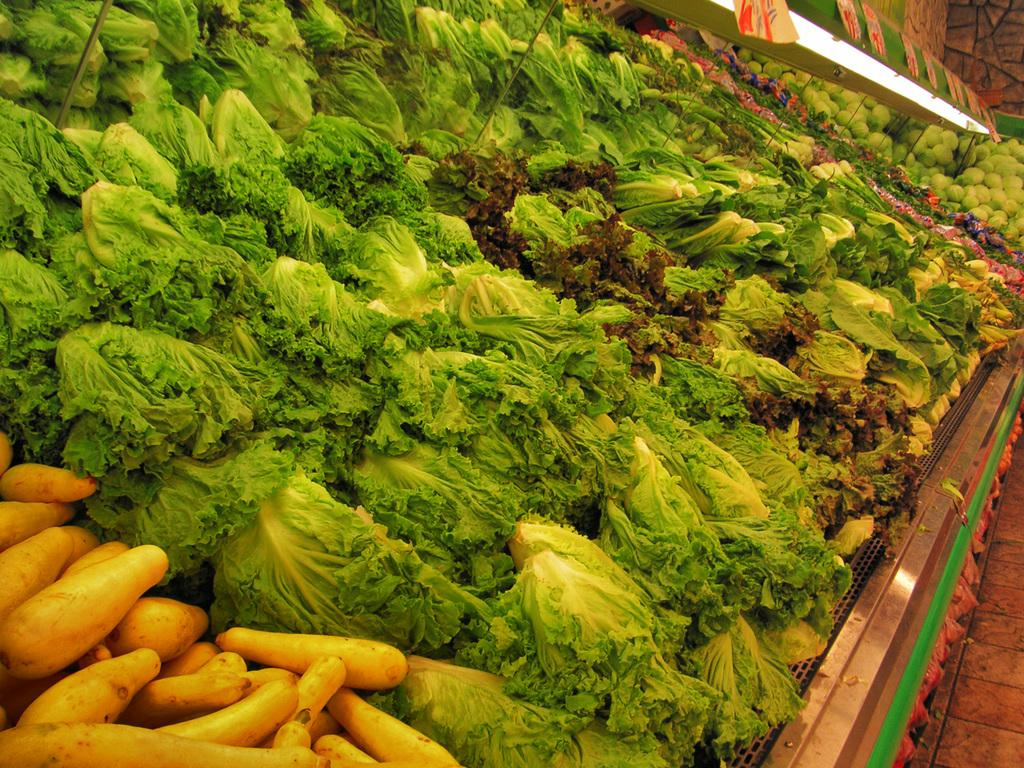What type of vegetables can be seen in the image? There are many vegetables in the image. Can you describe the lighting in the image? There is a light at the top of the image. What type of grass is growing in the image? There is no grass visible in the image; it only features vegetables and a light. 